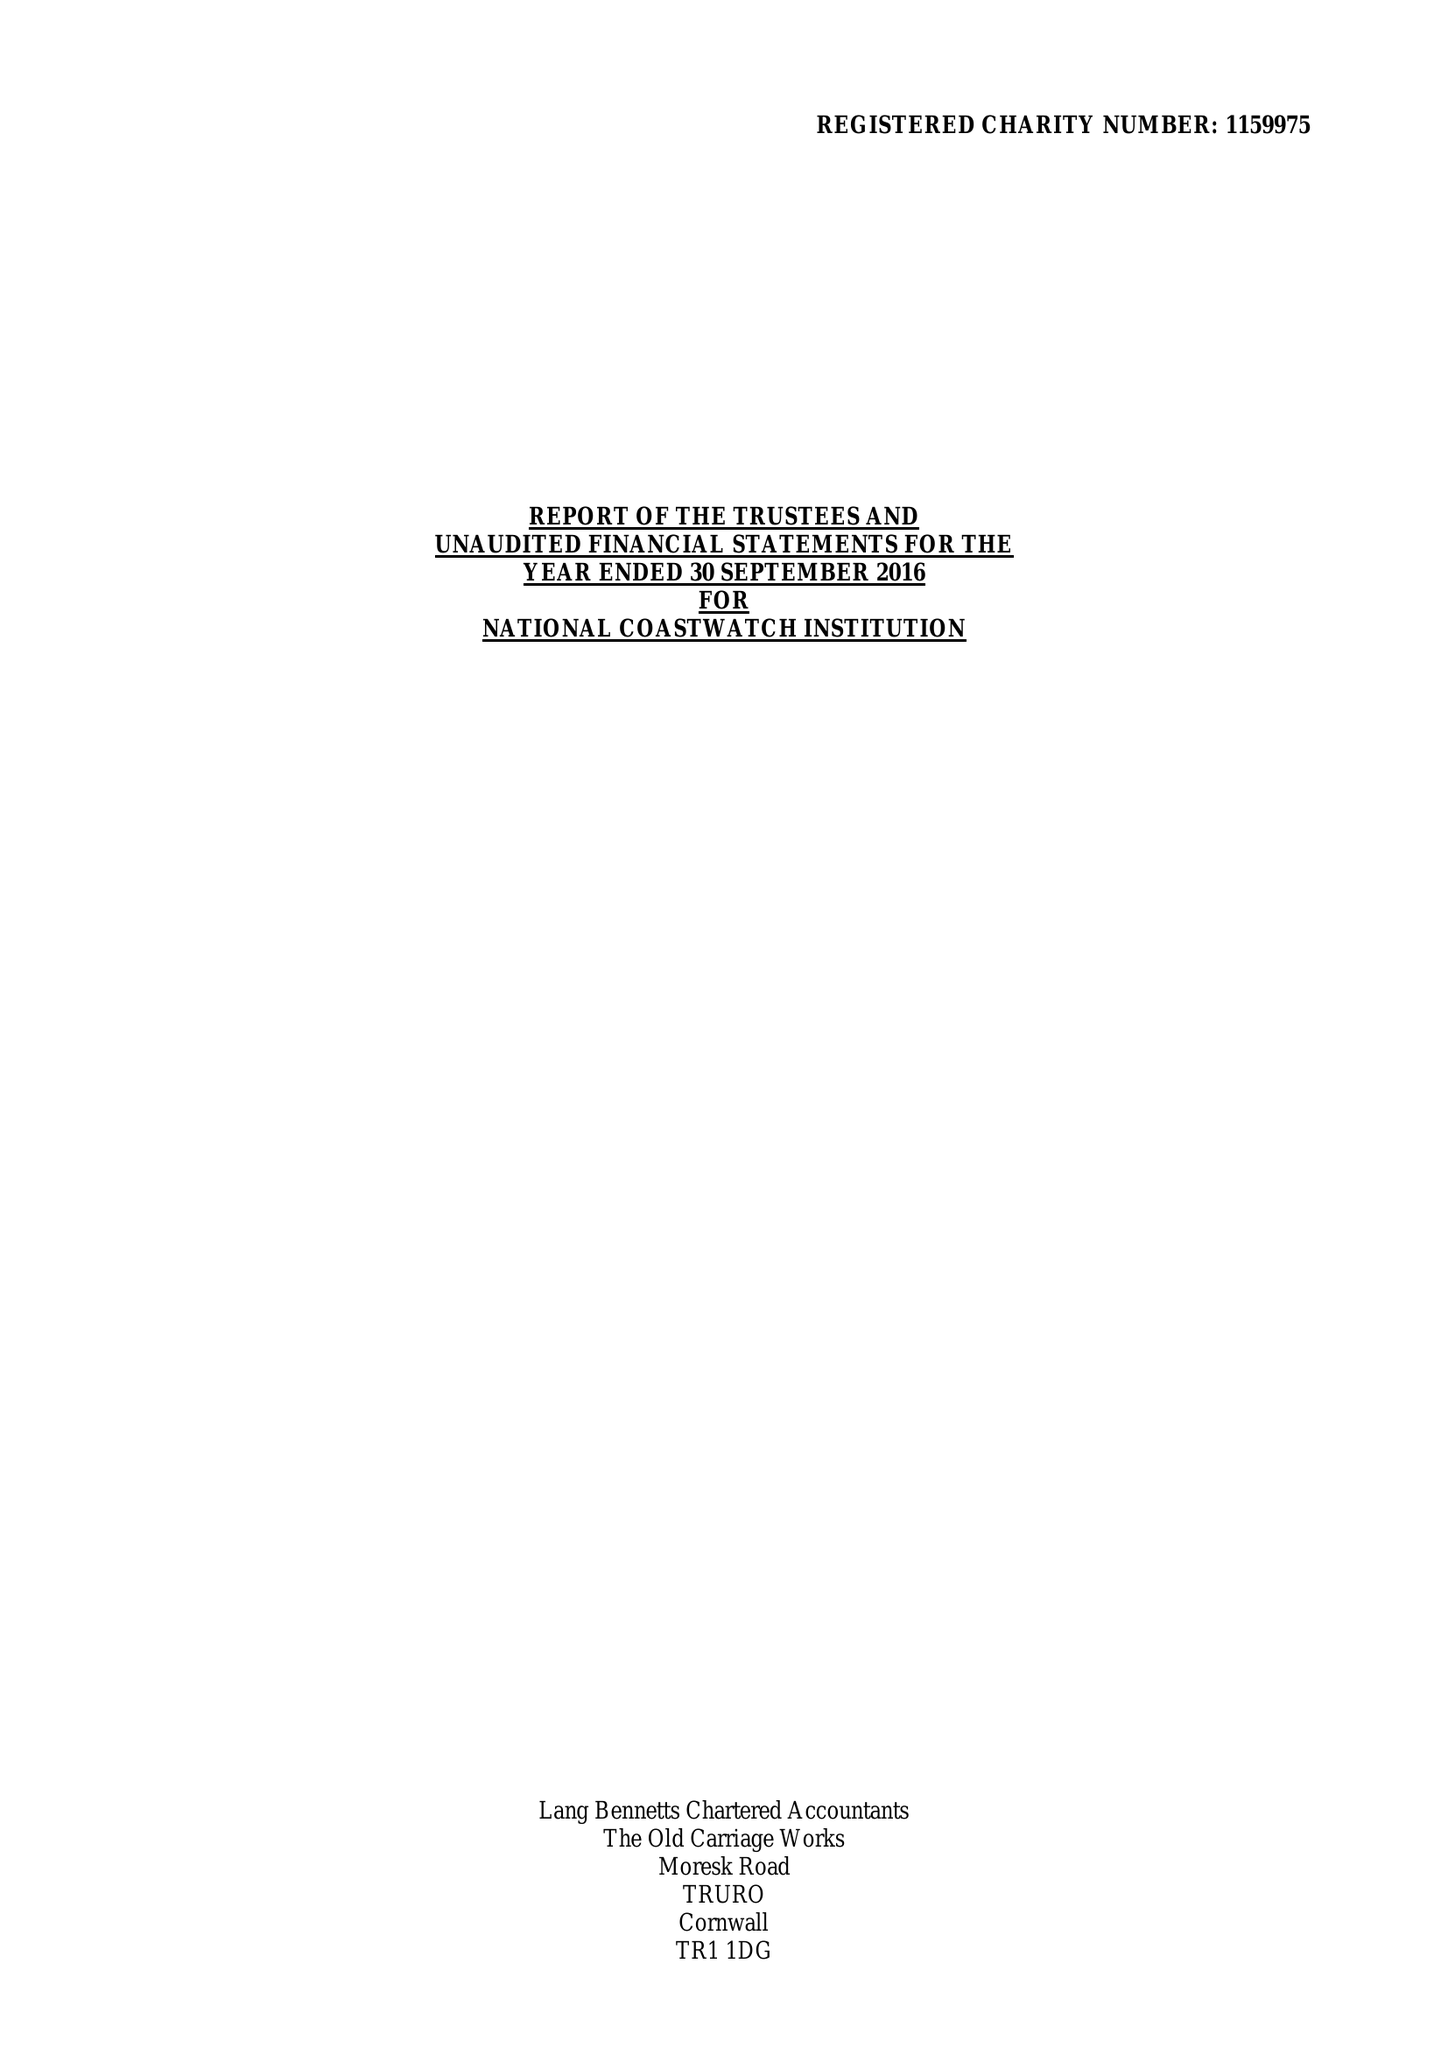What is the value for the report_date?
Answer the question using a single word or phrase. 2016-09-30 